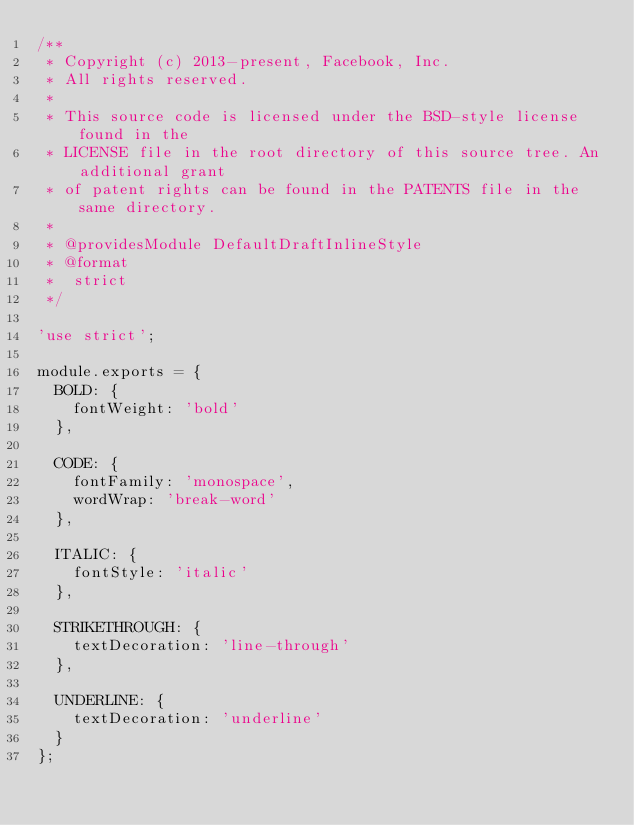Convert code to text. <code><loc_0><loc_0><loc_500><loc_500><_JavaScript_>/**
 * Copyright (c) 2013-present, Facebook, Inc.
 * All rights reserved.
 *
 * This source code is licensed under the BSD-style license found in the
 * LICENSE file in the root directory of this source tree. An additional grant
 * of patent rights can be found in the PATENTS file in the same directory.
 *
 * @providesModule DefaultDraftInlineStyle
 * @format
 *  strict
 */

'use strict';

module.exports = {
  BOLD: {
    fontWeight: 'bold'
  },

  CODE: {
    fontFamily: 'monospace',
    wordWrap: 'break-word'
  },

  ITALIC: {
    fontStyle: 'italic'
  },

  STRIKETHROUGH: {
    textDecoration: 'line-through'
  },

  UNDERLINE: {
    textDecoration: 'underline'
  }
};</code> 